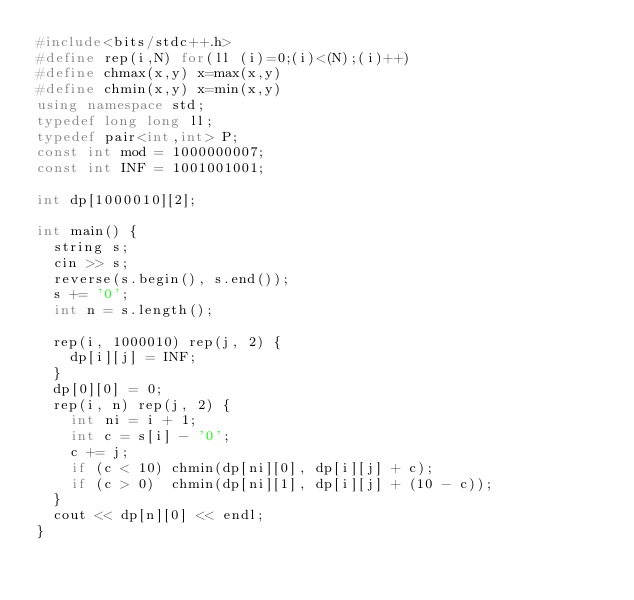Convert code to text. <code><loc_0><loc_0><loc_500><loc_500><_C++_>#include<bits/stdc++.h>
#define rep(i,N) for(ll (i)=0;(i)<(N);(i)++)
#define chmax(x,y) x=max(x,y)
#define chmin(x,y) x=min(x,y)
using namespace std;
typedef long long ll;
typedef pair<int,int> P;
const int mod = 1000000007;
const int INF = 1001001001;

int dp[1000010][2];

int main() {
  string s;
  cin >> s;
  reverse(s.begin(), s.end());
  s += '0';
  int n = s.length();

  rep(i, 1000010) rep(j, 2) {
    dp[i][j] = INF;
  }
  dp[0][0] = 0;
  rep(i, n) rep(j, 2) {
    int ni = i + 1;
    int c = s[i] - '0';
    c += j;
    if (c < 10) chmin(dp[ni][0], dp[i][j] + c);
    if (c > 0)  chmin(dp[ni][1], dp[i][j] + (10 - c));
  }
  cout << dp[n][0] << endl;
}</code> 